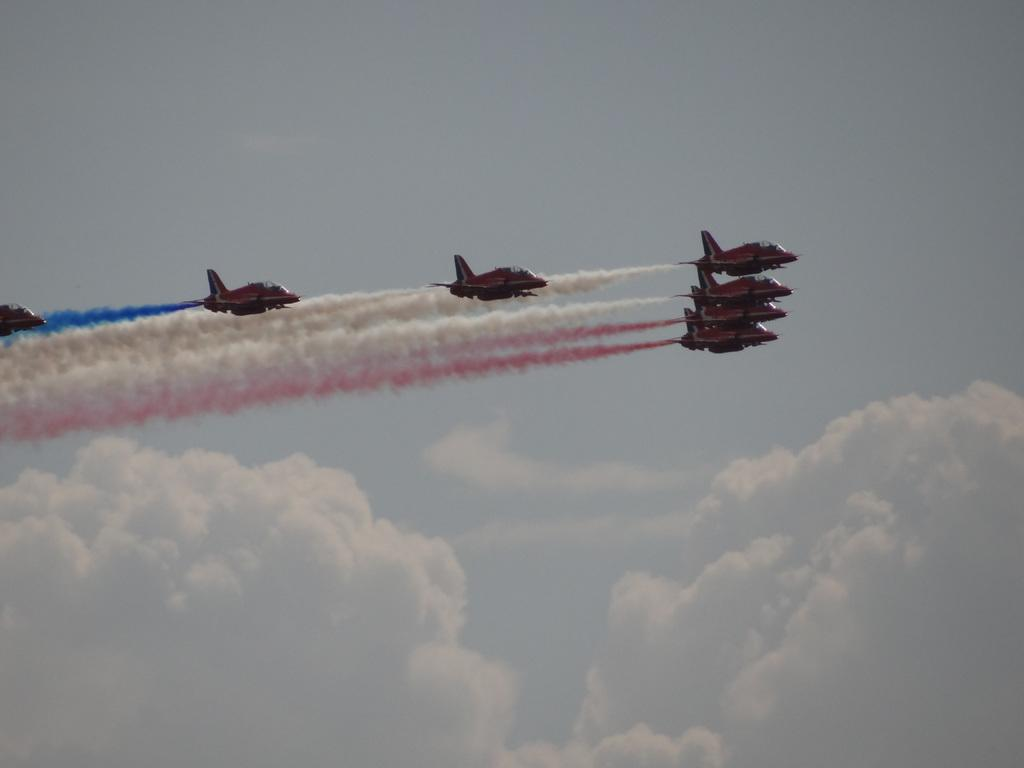What is happening in the image? There are airplanes flying in the image. What can be seen in the background of the image? The sky is visible in the background of the image. What is the condition of the sky in the image? Clouds are present in the sky. What type of partner can be seen interacting with the tiger in the image? There is no partner or tiger present in the image; it only features airplanes flying in the sky. 